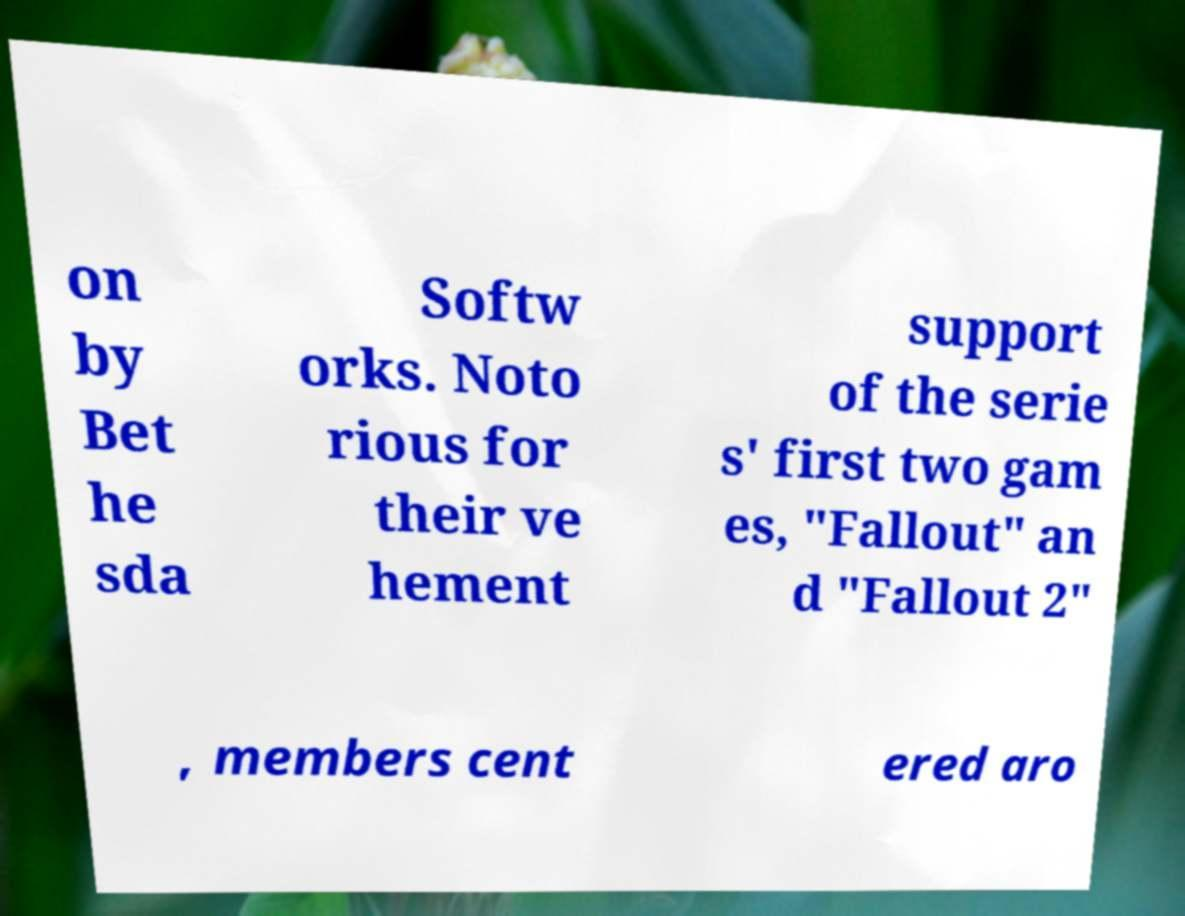I need the written content from this picture converted into text. Can you do that? on by Bet he sda Softw orks. Noto rious for their ve hement support of the serie s' first two gam es, "Fallout" an d "Fallout 2" , members cent ered aro 